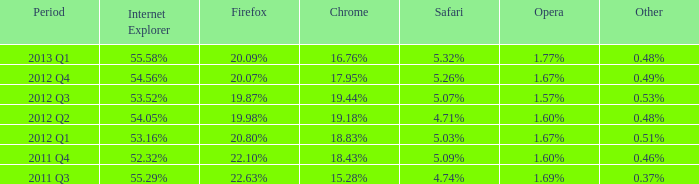What is the alternative that has 2 0.51%. 